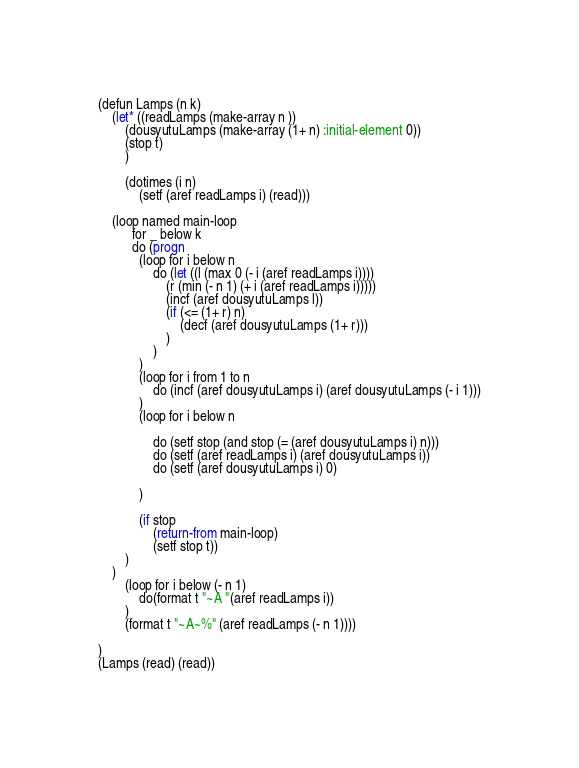Convert code to text. <code><loc_0><loc_0><loc_500><loc_500><_Lisp_>(defun Lamps (n k)
    (let* ((readLamps (make-array n ))
        (dousyutuLamps (make-array (1+ n) :initial-element 0))
        (stop t)
        )
 
        (dotimes (i n) 
            (setf (aref readLamps i) (read)))
 
    (loop named main-loop
          for _ below k
          do (progn 
            (loop for i below n
                do (let ((l (max 0 (- i (aref readLamps i))))
                    (r (min (- n 1) (+ i (aref readLamps i)))))
                    (incf (aref dousyutuLamps l))
                    (if (<= (1+ r) n)
                        (decf (aref dousyutuLamps (1+ r)))
                    )
                )                    
            )
            (loop for i from 1 to n
                do (incf (aref dousyutuLamps i) (aref dousyutuLamps (- i 1)))
            )
            (loop for i below n
                 
                do (setf stop (and stop (= (aref dousyutuLamps i) n)))
                do (setf (aref readLamps i) (aref dousyutuLamps i))
                do (setf (aref dousyutuLamps i) 0)
                
            ) 
            
            (if stop
                (return-from main-loop)
                (setf stop t))
        )
    )
        (loop for i below (- n 1)
            do(format t "~A "(aref readLamps i))
        )
        (format t "~A~%" (aref readLamps (- n 1))))
    
)
(Lamps (read) (read))</code> 